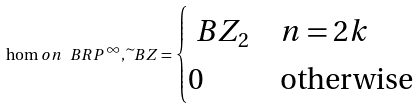<formula> <loc_0><loc_0><loc_500><loc_500>\hom o { n } { \ B R P ^ { \infty } , \widetilde { \ } B Z } = \begin{cases} \ B Z _ { 2 } & n = 2 k \\ 0 & \text {otherwise} \end{cases}</formula> 